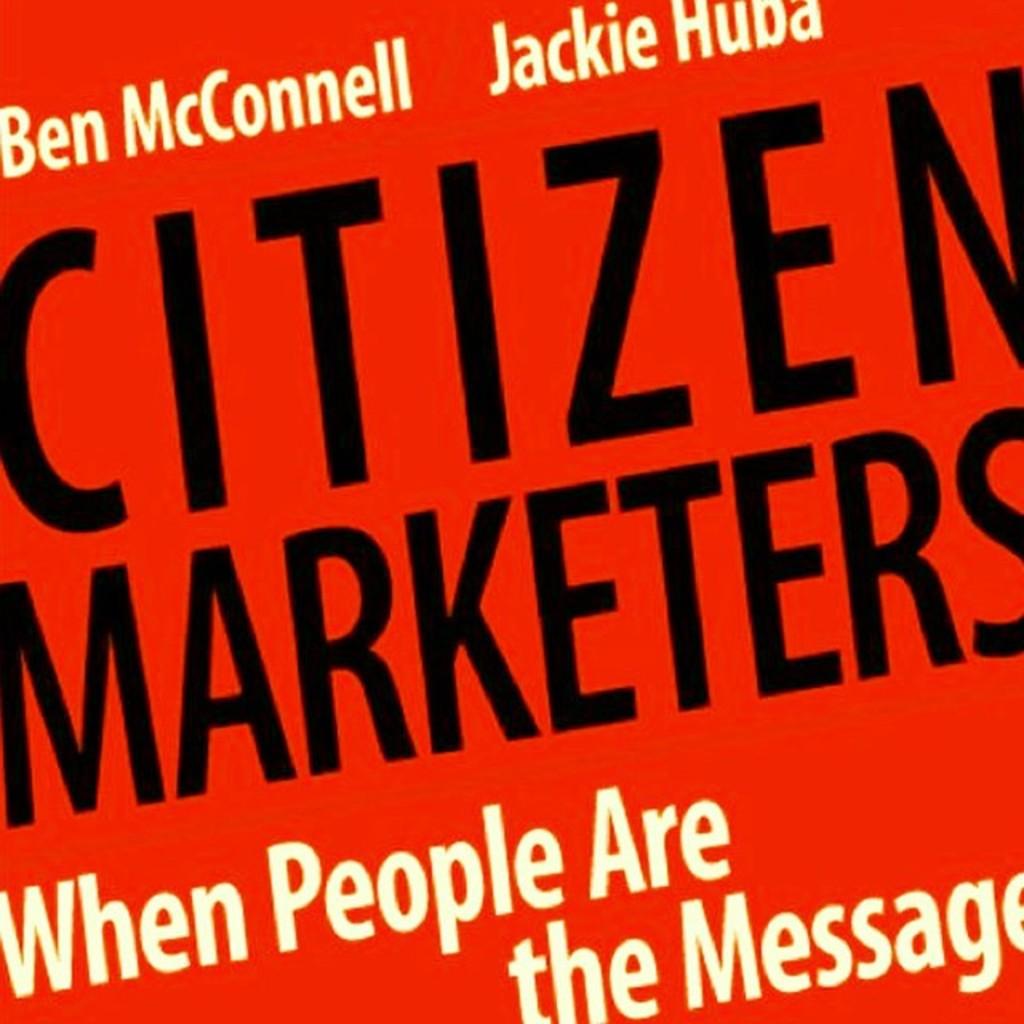Who are the authors of this book?
Keep it short and to the point. Ben mcconnell jackie huba. 